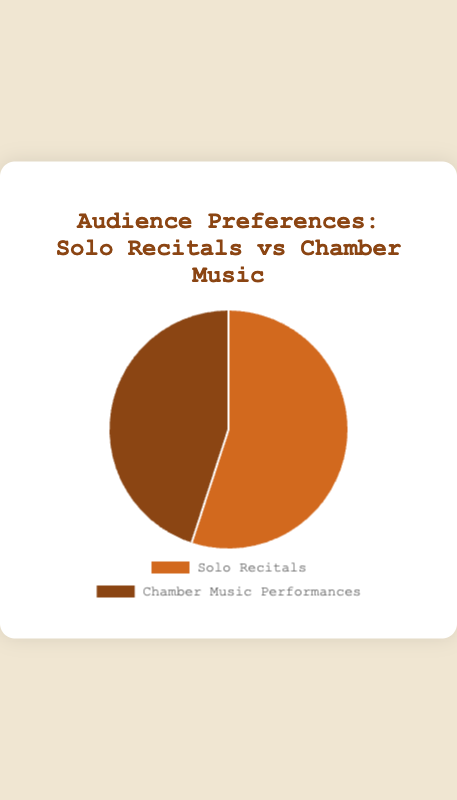Which performance type has the higher percentage of audience preference? The chart shows two performance types with their respective audience preferences. By observing the data points, "Solo Recitals" has a 55% preference while "Chamber Music Performances" has a 45% preference. Therefore, "Solo Recitals" has the higher percentage.
Answer: Solo Recitals What is the difference in audience preference between Solo Recitals and Chamber Music Performances? The data points in the chart indicate that "Solo Recitals" have a 55% audience preference while "Chamber Music Performances" have a 45% preference. To find the difference, subtract 45% from 55%, which equals 10%.
Answer: 10% Which segment is represented by the orange color? The colors used in the chart distinguish between the different performance types. Observing the chart, the segment represented by the orange color corresponds to "Solo Recitals."
Answer: Solo Recitals If you want to emphasize a balanced program, which performance type would need a 10% increase in preference to create an equal share? To achieve an equal share in audience preference, both performance types need to have a preference of 50%. Currently, "Chamber Music Performances" have a 45% preference. To reach 50%, "Chamber Music Performances" would need an increase of 5%.
Answer: Chamber Music Performances What percentage of the audience prefers Chamber Music Performances? Based purely on the chart data, "Chamber Music Performances" are preferred by 45% of the audience.
Answer: 45% How much is the total percentage covered by both performance types together? Adding the percentages of both performance types, 55% for "Solo Recitals" and 45% for "Chamber Music Performances," we get a total of 100%.
Answer: 100% Which performance type has a lower audience preference, and by what percentage? By examining the chart, "Chamber Music Performances" have a 45% preference, which is lower compared to "Solo Recitals" at 55%. The difference in audience preference is 55% - 45% = 10%.
Answer: Chamber Music Performances, 10% Are the proportions of Solo Recitals and Chamber Music Performances approximately equal or very different? To analyze the proportions, observe the percentages: 55% for "Solo Recitals" and 45% for "Chamber Music Performances." The difference is 10%, indicating that the preferences are fairly close but not exactly equal.
Answer: Fairly close 